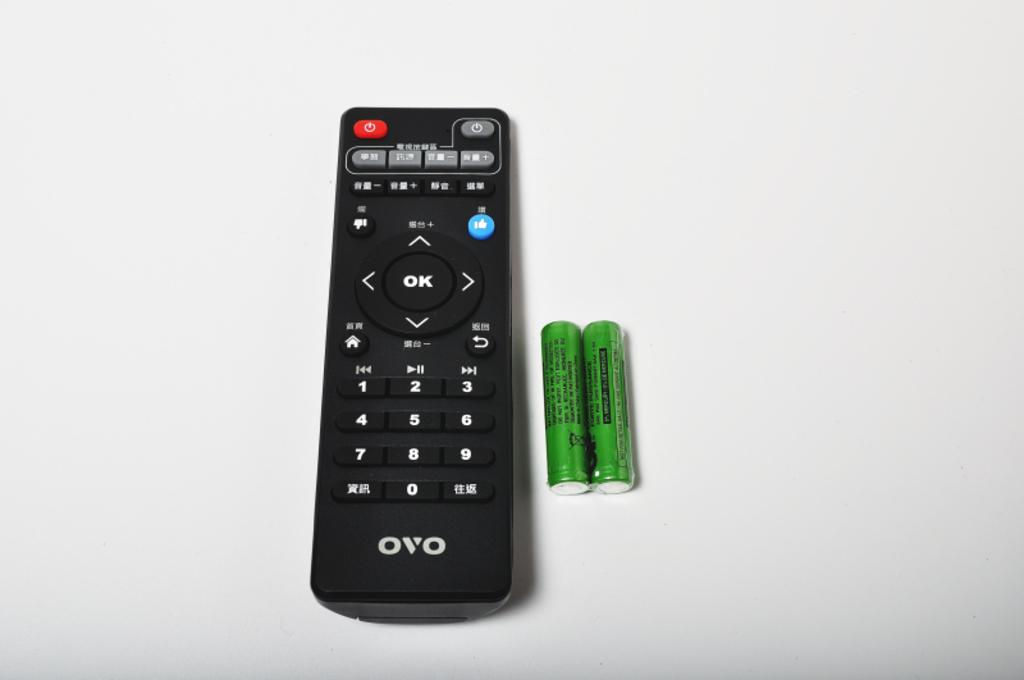<image>
Offer a succinct explanation of the picture presented. A remote control made by the company OVO. 